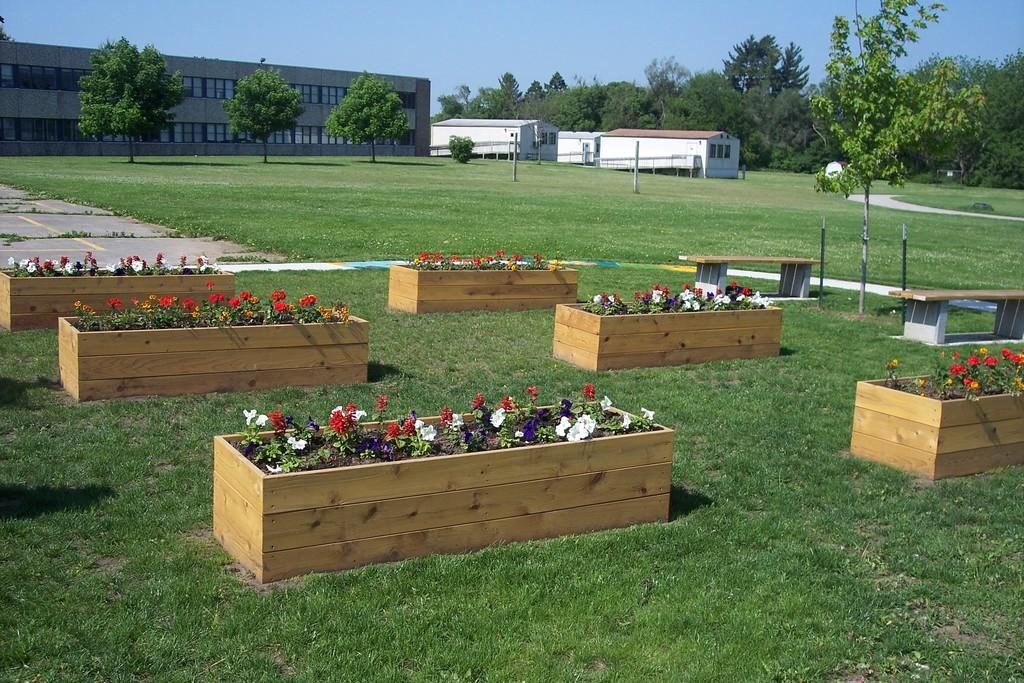What can be seen in the sky in the image? There is sky visible in the image. What type of structure is present in the image? There is a building in the image. What type of residential structures are present in the image? There are houses in the image. What type of vegetation can be seen in the image? There are trees and grass in the image. What type of flora can be seen in the image? There are flowers in the image. How many letters are visible on the flowers in the image? There are no letters present on the flowers in the image. What type of nerve can be seen in the image? There are no nerves present in the image. 